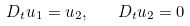<formula> <loc_0><loc_0><loc_500><loc_500>D _ { t } u _ { 1 } = u _ { 2 } , \quad D _ { t } u _ { 2 } = 0</formula> 